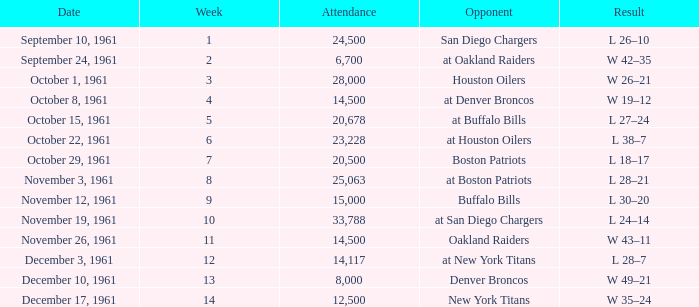What is the top attendance for weeks past 2 on october 29, 1961? 20500.0. 